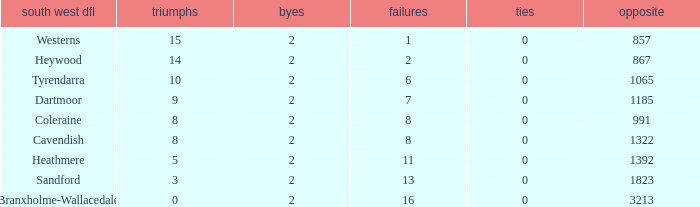Which draws have an average of 14 wins? 0.0. Could you parse the entire table? {'header': ['south west dfl', 'triumphs', 'byes', 'failures', 'ties', 'opposite'], 'rows': [['Westerns', '15', '2', '1', '0', '857'], ['Heywood', '14', '2', '2', '0', '867'], ['Tyrendarra', '10', '2', '6', '0', '1065'], ['Dartmoor', '9', '2', '7', '0', '1185'], ['Coleraine', '8', '2', '8', '0', '991'], ['Cavendish', '8', '2', '8', '0', '1322'], ['Heathmere', '5', '2', '11', '0', '1392'], ['Sandford', '3', '2', '13', '0', '1823'], ['Branxholme-Wallacedale', '0', '2', '16', '0', '3213']]} 